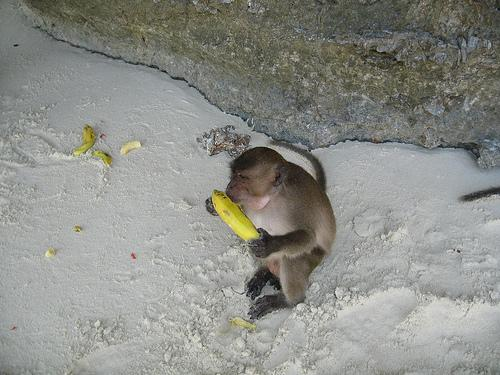What is the color of the objects near the monkey? The objects near the monkey are yellow, which are bananas and banana peels. Analyze the complexity of reasoning required to understand the image. The image requires moderate complexity of reasoning, as it involves a monkey with various body parts and actions, interacting with bananas and other objects in a snowy environment. Provide a detailed description of the monkey's appearance. The monkey has a long tail, claws, head with eyes, nose, ear, and mouth, arms, feet, and a hand holding a banana. What are the main objects in the image, and what is the environment like? The main objects are the monkey with a banana and a rock. The environment is a snowy plain. State the primary subject in the image and what the subject is interacting with. The primary subject is a monkey, and it is interacting with a banana. Count the total number of objects in the image. There are at least 16 distinct objects in the image. Determine the mood or sentiment conveyed by the image. The image conveys a playful and curious mood, as the monkey is interacting with the banana in a snow-covered environment. Identify the main object in the image and its action. The monkey is the main object, and it is holding and eating a banana. List all the objects related to the monkey. Banana, banana peel, long tail, claws, footprints, head, arm, thigh, feet, ear, eyes, nose, mouth, hand, and body. What is the condition of the banana in the image? The banana is yellow, with both peeled and unpeeled portions. Describe the colors and attributes of the banana. Yellow and unpeeled Are there any unusual or unexpected objects in the image? No, all the objects are related to the scene. Select the true statement: a) the monkey is not eating the banana, b) there are no footprints on the snow, c) a big rock is beside the monkey. c) a big rock is beside the monkey Is the monkey standing on the big rock?  No, it's not mentioned in the image. What emotion does the image evoke? Amusement and delight. Identify the relationships between the objects in the image. The monkey is eating and holding the banana, banana peel is on the ground, footprints are in the snow, and the rock is beside the monkey. Find any inconsistencies or oddities within the image. No inconsistencies or oddities found. Categorize the visible parts of the monkey in the image. Head: ear, eyes, nose, mouth. Body: arm, hand. Tail: long tail. Feet: visible feet. Is there any text or numeric information visible in the image? No What is the overall sentiment conveyed by the image? Playful and curious. Rate the quality of the image from 1 to 5, with 5 being the highest quality. 4 Describe the main objects and actions taking place in the image. A monkey holding and eating a banana with its tail, arm, body, and feet visible, banana peel on the ground, a big rock, and footprints on snow. Examine the interactions between the monkey and its surroundings. The monkey seems to be alone in the snowy area, eating a banana with a big rock behind it and footprints around. Evaluate the clarity and composition of the image. The image is clear and well composed. Provide a brief narrative of the scene in the image. A monkey is enjoying eating a banana while standing on snow, with a big rock nearby and footprints in the snow, as some banana peel is on the ground. What color is the banana? Yellow Is the monkey picking up banana pieces with its hand? This instruction assumes that the monkey is involved in an action with the banana pieces, but the given information doesn't suggest anything in that regard. This may lead someone to search for a connection between the monkey and the banana pieces that isn't implied from the image data. List all the objects detected in the image. Monkey, banana, banana peel, tail, arm, body, feet, ear, eyes, nose, mouth, hand, big rock, footprints, snow, stone, wall, part of a thigh, part of a monkey, part of a rock, part of a banana. Which of the following statements is true about the image: a) the monkey is eating an apple, b) the monkey has a short tail, c) the banana peel is on the ground? c) the banana peel is on the ground How many parts of the rock can you identify in the image? 3 